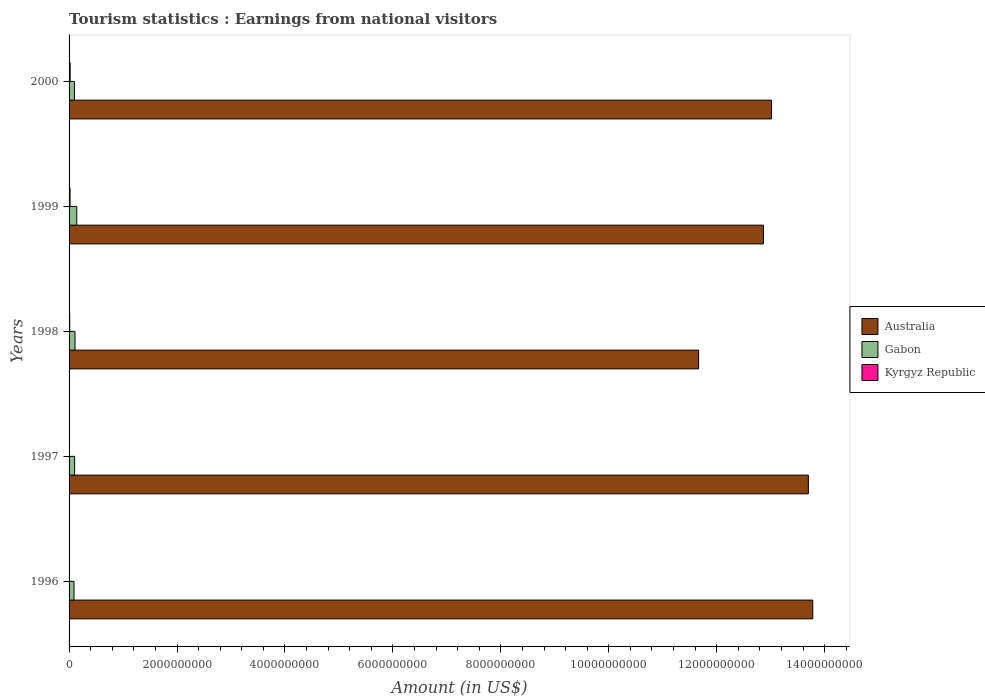How many groups of bars are there?
Your response must be concise. 5. Are the number of bars per tick equal to the number of legend labels?
Offer a very short reply. Yes. Are the number of bars on each tick of the Y-axis equal?
Keep it short and to the point. Yes. In how many cases, is the number of bars for a given year not equal to the number of legend labels?
Your response must be concise. 0. What is the earnings from national visitors in Gabon in 2000?
Ensure brevity in your answer.  9.90e+07. Across all years, what is the maximum earnings from national visitors in Kyrgyz Republic?
Offer a terse response. 2.00e+07. Across all years, what is the minimum earnings from national visitors in Kyrgyz Republic?
Make the answer very short. 4.00e+06. In which year was the earnings from national visitors in Gabon maximum?
Your answer should be very brief. 1999. In which year was the earnings from national visitors in Gabon minimum?
Provide a succinct answer. 1996. What is the total earnings from national visitors in Gabon in the graph?
Provide a short and direct response. 5.46e+08. What is the difference between the earnings from national visitors in Kyrgyz Republic in 1999 and that in 2000?
Make the answer very short. -2.00e+06. What is the difference between the earnings from national visitors in Australia in 1996 and the earnings from national visitors in Kyrgyz Republic in 2000?
Offer a very short reply. 1.38e+1. What is the average earnings from national visitors in Kyrgyz Republic per year?
Make the answer very short. 1.22e+07. In the year 1999, what is the difference between the earnings from national visitors in Kyrgyz Republic and earnings from national visitors in Australia?
Make the answer very short. -1.28e+1. In how many years, is the earnings from national visitors in Gabon greater than 11600000000 US$?
Ensure brevity in your answer.  0. What is the ratio of the earnings from national visitors in Australia in 1998 to that in 1999?
Provide a short and direct response. 0.91. Is the earnings from national visitors in Gabon in 1996 less than that in 2000?
Provide a short and direct response. Yes. Is the difference between the earnings from national visitors in Kyrgyz Republic in 1998 and 1999 greater than the difference between the earnings from national visitors in Australia in 1998 and 1999?
Your response must be concise. Yes. What is the difference between the highest and the second highest earnings from national visitors in Gabon?
Your answer should be very brief. 3.30e+07. What is the difference between the highest and the lowest earnings from national visitors in Gabon?
Ensure brevity in your answer.  5.20e+07. In how many years, is the earnings from national visitors in Australia greater than the average earnings from national visitors in Australia taken over all years?
Ensure brevity in your answer.  3. Is the sum of the earnings from national visitors in Australia in 1996 and 1998 greater than the maximum earnings from national visitors in Gabon across all years?
Offer a terse response. Yes. What does the 1st bar from the top in 2000 represents?
Ensure brevity in your answer.  Kyrgyz Republic. How many bars are there?
Your answer should be compact. 15. Are all the bars in the graph horizontal?
Your response must be concise. Yes. How many years are there in the graph?
Keep it short and to the point. 5. What is the difference between two consecutive major ticks on the X-axis?
Your response must be concise. 2.00e+09. Does the graph contain any zero values?
Provide a short and direct response. No. Does the graph contain grids?
Ensure brevity in your answer.  No. Where does the legend appear in the graph?
Ensure brevity in your answer.  Center right. How many legend labels are there?
Offer a terse response. 3. What is the title of the graph?
Your answer should be compact. Tourism statistics : Earnings from national visitors. Does "Georgia" appear as one of the legend labels in the graph?
Provide a succinct answer. No. What is the label or title of the X-axis?
Offer a terse response. Amount (in US$). What is the Amount (in US$) of Australia in 1996?
Keep it short and to the point. 1.38e+1. What is the Amount (in US$) in Gabon in 1996?
Offer a terse response. 9.10e+07. What is the Amount (in US$) in Kyrgyz Republic in 1996?
Ensure brevity in your answer.  4.00e+06. What is the Amount (in US$) of Australia in 1997?
Offer a terse response. 1.37e+1. What is the Amount (in US$) in Gabon in 1997?
Make the answer very short. 1.03e+08. What is the Amount (in US$) of Kyrgyz Republic in 1997?
Provide a short and direct response. 7.00e+06. What is the Amount (in US$) of Australia in 1998?
Offer a very short reply. 1.17e+1. What is the Amount (in US$) of Gabon in 1998?
Offer a terse response. 1.10e+08. What is the Amount (in US$) in Australia in 1999?
Your answer should be very brief. 1.29e+1. What is the Amount (in US$) in Gabon in 1999?
Make the answer very short. 1.43e+08. What is the Amount (in US$) of Kyrgyz Republic in 1999?
Offer a terse response. 1.80e+07. What is the Amount (in US$) of Australia in 2000?
Offer a terse response. 1.30e+1. What is the Amount (in US$) in Gabon in 2000?
Give a very brief answer. 9.90e+07. Across all years, what is the maximum Amount (in US$) in Australia?
Offer a terse response. 1.38e+1. Across all years, what is the maximum Amount (in US$) of Gabon?
Keep it short and to the point. 1.43e+08. Across all years, what is the minimum Amount (in US$) in Australia?
Your response must be concise. 1.17e+1. Across all years, what is the minimum Amount (in US$) in Gabon?
Your answer should be compact. 9.10e+07. Across all years, what is the minimum Amount (in US$) in Kyrgyz Republic?
Give a very brief answer. 4.00e+06. What is the total Amount (in US$) of Australia in the graph?
Ensure brevity in your answer.  6.50e+1. What is the total Amount (in US$) in Gabon in the graph?
Make the answer very short. 5.46e+08. What is the total Amount (in US$) of Kyrgyz Republic in the graph?
Make the answer very short. 6.10e+07. What is the difference between the Amount (in US$) of Australia in 1996 and that in 1997?
Offer a terse response. 8.10e+07. What is the difference between the Amount (in US$) of Gabon in 1996 and that in 1997?
Give a very brief answer. -1.20e+07. What is the difference between the Amount (in US$) of Kyrgyz Republic in 1996 and that in 1997?
Keep it short and to the point. -3.00e+06. What is the difference between the Amount (in US$) of Australia in 1996 and that in 1998?
Keep it short and to the point. 2.12e+09. What is the difference between the Amount (in US$) in Gabon in 1996 and that in 1998?
Offer a terse response. -1.90e+07. What is the difference between the Amount (in US$) of Kyrgyz Republic in 1996 and that in 1998?
Give a very brief answer. -8.00e+06. What is the difference between the Amount (in US$) in Australia in 1996 and that in 1999?
Make the answer very short. 9.13e+08. What is the difference between the Amount (in US$) of Gabon in 1996 and that in 1999?
Make the answer very short. -5.20e+07. What is the difference between the Amount (in US$) in Kyrgyz Republic in 1996 and that in 1999?
Your answer should be compact. -1.40e+07. What is the difference between the Amount (in US$) in Australia in 1996 and that in 2000?
Ensure brevity in your answer.  7.63e+08. What is the difference between the Amount (in US$) in Gabon in 1996 and that in 2000?
Your response must be concise. -8.00e+06. What is the difference between the Amount (in US$) of Kyrgyz Republic in 1996 and that in 2000?
Keep it short and to the point. -1.60e+07. What is the difference between the Amount (in US$) of Australia in 1997 and that in 1998?
Offer a very short reply. 2.03e+09. What is the difference between the Amount (in US$) of Gabon in 1997 and that in 1998?
Offer a terse response. -7.00e+06. What is the difference between the Amount (in US$) of Kyrgyz Republic in 1997 and that in 1998?
Your answer should be compact. -5.00e+06. What is the difference between the Amount (in US$) in Australia in 1997 and that in 1999?
Give a very brief answer. 8.32e+08. What is the difference between the Amount (in US$) in Gabon in 1997 and that in 1999?
Offer a very short reply. -4.00e+07. What is the difference between the Amount (in US$) of Kyrgyz Republic in 1997 and that in 1999?
Make the answer very short. -1.10e+07. What is the difference between the Amount (in US$) in Australia in 1997 and that in 2000?
Ensure brevity in your answer.  6.82e+08. What is the difference between the Amount (in US$) of Gabon in 1997 and that in 2000?
Provide a short and direct response. 4.00e+06. What is the difference between the Amount (in US$) of Kyrgyz Republic in 1997 and that in 2000?
Your answer should be compact. -1.30e+07. What is the difference between the Amount (in US$) in Australia in 1998 and that in 1999?
Offer a terse response. -1.20e+09. What is the difference between the Amount (in US$) of Gabon in 1998 and that in 1999?
Your answer should be compact. -3.30e+07. What is the difference between the Amount (in US$) of Kyrgyz Republic in 1998 and that in 1999?
Give a very brief answer. -6.00e+06. What is the difference between the Amount (in US$) in Australia in 1998 and that in 2000?
Your answer should be compact. -1.35e+09. What is the difference between the Amount (in US$) in Gabon in 1998 and that in 2000?
Provide a short and direct response. 1.10e+07. What is the difference between the Amount (in US$) of Kyrgyz Republic in 1998 and that in 2000?
Offer a terse response. -8.00e+06. What is the difference between the Amount (in US$) of Australia in 1999 and that in 2000?
Offer a terse response. -1.50e+08. What is the difference between the Amount (in US$) in Gabon in 1999 and that in 2000?
Ensure brevity in your answer.  4.40e+07. What is the difference between the Amount (in US$) in Kyrgyz Republic in 1999 and that in 2000?
Your answer should be compact. -2.00e+06. What is the difference between the Amount (in US$) of Australia in 1996 and the Amount (in US$) of Gabon in 1997?
Provide a succinct answer. 1.37e+1. What is the difference between the Amount (in US$) of Australia in 1996 and the Amount (in US$) of Kyrgyz Republic in 1997?
Provide a short and direct response. 1.38e+1. What is the difference between the Amount (in US$) in Gabon in 1996 and the Amount (in US$) in Kyrgyz Republic in 1997?
Provide a short and direct response. 8.40e+07. What is the difference between the Amount (in US$) in Australia in 1996 and the Amount (in US$) in Gabon in 1998?
Provide a succinct answer. 1.37e+1. What is the difference between the Amount (in US$) of Australia in 1996 and the Amount (in US$) of Kyrgyz Republic in 1998?
Your answer should be compact. 1.38e+1. What is the difference between the Amount (in US$) in Gabon in 1996 and the Amount (in US$) in Kyrgyz Republic in 1998?
Ensure brevity in your answer.  7.90e+07. What is the difference between the Amount (in US$) of Australia in 1996 and the Amount (in US$) of Gabon in 1999?
Give a very brief answer. 1.36e+1. What is the difference between the Amount (in US$) in Australia in 1996 and the Amount (in US$) in Kyrgyz Republic in 1999?
Your answer should be compact. 1.38e+1. What is the difference between the Amount (in US$) in Gabon in 1996 and the Amount (in US$) in Kyrgyz Republic in 1999?
Your answer should be very brief. 7.30e+07. What is the difference between the Amount (in US$) of Australia in 1996 and the Amount (in US$) of Gabon in 2000?
Keep it short and to the point. 1.37e+1. What is the difference between the Amount (in US$) in Australia in 1996 and the Amount (in US$) in Kyrgyz Republic in 2000?
Your response must be concise. 1.38e+1. What is the difference between the Amount (in US$) of Gabon in 1996 and the Amount (in US$) of Kyrgyz Republic in 2000?
Offer a very short reply. 7.10e+07. What is the difference between the Amount (in US$) of Australia in 1997 and the Amount (in US$) of Gabon in 1998?
Make the answer very short. 1.36e+1. What is the difference between the Amount (in US$) in Australia in 1997 and the Amount (in US$) in Kyrgyz Republic in 1998?
Ensure brevity in your answer.  1.37e+1. What is the difference between the Amount (in US$) in Gabon in 1997 and the Amount (in US$) in Kyrgyz Republic in 1998?
Offer a terse response. 9.10e+07. What is the difference between the Amount (in US$) of Australia in 1997 and the Amount (in US$) of Gabon in 1999?
Your answer should be compact. 1.36e+1. What is the difference between the Amount (in US$) in Australia in 1997 and the Amount (in US$) in Kyrgyz Republic in 1999?
Offer a very short reply. 1.37e+1. What is the difference between the Amount (in US$) in Gabon in 1997 and the Amount (in US$) in Kyrgyz Republic in 1999?
Keep it short and to the point. 8.50e+07. What is the difference between the Amount (in US$) in Australia in 1997 and the Amount (in US$) in Gabon in 2000?
Provide a short and direct response. 1.36e+1. What is the difference between the Amount (in US$) of Australia in 1997 and the Amount (in US$) of Kyrgyz Republic in 2000?
Keep it short and to the point. 1.37e+1. What is the difference between the Amount (in US$) of Gabon in 1997 and the Amount (in US$) of Kyrgyz Republic in 2000?
Your answer should be very brief. 8.30e+07. What is the difference between the Amount (in US$) of Australia in 1998 and the Amount (in US$) of Gabon in 1999?
Provide a succinct answer. 1.15e+1. What is the difference between the Amount (in US$) in Australia in 1998 and the Amount (in US$) in Kyrgyz Republic in 1999?
Offer a terse response. 1.16e+1. What is the difference between the Amount (in US$) of Gabon in 1998 and the Amount (in US$) of Kyrgyz Republic in 1999?
Give a very brief answer. 9.20e+07. What is the difference between the Amount (in US$) of Australia in 1998 and the Amount (in US$) of Gabon in 2000?
Your answer should be very brief. 1.16e+1. What is the difference between the Amount (in US$) in Australia in 1998 and the Amount (in US$) in Kyrgyz Republic in 2000?
Make the answer very short. 1.16e+1. What is the difference between the Amount (in US$) in Gabon in 1998 and the Amount (in US$) in Kyrgyz Republic in 2000?
Your answer should be very brief. 9.00e+07. What is the difference between the Amount (in US$) of Australia in 1999 and the Amount (in US$) of Gabon in 2000?
Provide a short and direct response. 1.28e+1. What is the difference between the Amount (in US$) in Australia in 1999 and the Amount (in US$) in Kyrgyz Republic in 2000?
Offer a very short reply. 1.28e+1. What is the difference between the Amount (in US$) of Gabon in 1999 and the Amount (in US$) of Kyrgyz Republic in 2000?
Your response must be concise. 1.23e+08. What is the average Amount (in US$) in Australia per year?
Your response must be concise. 1.30e+1. What is the average Amount (in US$) of Gabon per year?
Your answer should be very brief. 1.09e+08. What is the average Amount (in US$) of Kyrgyz Republic per year?
Provide a short and direct response. 1.22e+07. In the year 1996, what is the difference between the Amount (in US$) of Australia and Amount (in US$) of Gabon?
Your response must be concise. 1.37e+1. In the year 1996, what is the difference between the Amount (in US$) of Australia and Amount (in US$) of Kyrgyz Republic?
Your response must be concise. 1.38e+1. In the year 1996, what is the difference between the Amount (in US$) in Gabon and Amount (in US$) in Kyrgyz Republic?
Offer a terse response. 8.70e+07. In the year 1997, what is the difference between the Amount (in US$) in Australia and Amount (in US$) in Gabon?
Provide a succinct answer. 1.36e+1. In the year 1997, what is the difference between the Amount (in US$) in Australia and Amount (in US$) in Kyrgyz Republic?
Provide a succinct answer. 1.37e+1. In the year 1997, what is the difference between the Amount (in US$) in Gabon and Amount (in US$) in Kyrgyz Republic?
Provide a short and direct response. 9.60e+07. In the year 1998, what is the difference between the Amount (in US$) of Australia and Amount (in US$) of Gabon?
Keep it short and to the point. 1.16e+1. In the year 1998, what is the difference between the Amount (in US$) of Australia and Amount (in US$) of Kyrgyz Republic?
Your answer should be compact. 1.17e+1. In the year 1998, what is the difference between the Amount (in US$) in Gabon and Amount (in US$) in Kyrgyz Republic?
Your answer should be compact. 9.80e+07. In the year 1999, what is the difference between the Amount (in US$) of Australia and Amount (in US$) of Gabon?
Your response must be concise. 1.27e+1. In the year 1999, what is the difference between the Amount (in US$) in Australia and Amount (in US$) in Kyrgyz Republic?
Your response must be concise. 1.28e+1. In the year 1999, what is the difference between the Amount (in US$) in Gabon and Amount (in US$) in Kyrgyz Republic?
Provide a short and direct response. 1.25e+08. In the year 2000, what is the difference between the Amount (in US$) of Australia and Amount (in US$) of Gabon?
Provide a succinct answer. 1.29e+1. In the year 2000, what is the difference between the Amount (in US$) in Australia and Amount (in US$) in Kyrgyz Republic?
Offer a terse response. 1.30e+1. In the year 2000, what is the difference between the Amount (in US$) of Gabon and Amount (in US$) of Kyrgyz Republic?
Your answer should be compact. 7.90e+07. What is the ratio of the Amount (in US$) in Australia in 1996 to that in 1997?
Your answer should be compact. 1.01. What is the ratio of the Amount (in US$) of Gabon in 1996 to that in 1997?
Your answer should be very brief. 0.88. What is the ratio of the Amount (in US$) in Australia in 1996 to that in 1998?
Your answer should be very brief. 1.18. What is the ratio of the Amount (in US$) in Gabon in 1996 to that in 1998?
Keep it short and to the point. 0.83. What is the ratio of the Amount (in US$) of Australia in 1996 to that in 1999?
Make the answer very short. 1.07. What is the ratio of the Amount (in US$) in Gabon in 1996 to that in 1999?
Give a very brief answer. 0.64. What is the ratio of the Amount (in US$) of Kyrgyz Republic in 1996 to that in 1999?
Offer a terse response. 0.22. What is the ratio of the Amount (in US$) in Australia in 1996 to that in 2000?
Make the answer very short. 1.06. What is the ratio of the Amount (in US$) in Gabon in 1996 to that in 2000?
Provide a succinct answer. 0.92. What is the ratio of the Amount (in US$) of Kyrgyz Republic in 1996 to that in 2000?
Keep it short and to the point. 0.2. What is the ratio of the Amount (in US$) of Australia in 1997 to that in 1998?
Your answer should be very brief. 1.17. What is the ratio of the Amount (in US$) in Gabon in 1997 to that in 1998?
Make the answer very short. 0.94. What is the ratio of the Amount (in US$) of Kyrgyz Republic in 1997 to that in 1998?
Your answer should be very brief. 0.58. What is the ratio of the Amount (in US$) of Australia in 1997 to that in 1999?
Provide a short and direct response. 1.06. What is the ratio of the Amount (in US$) in Gabon in 1997 to that in 1999?
Provide a short and direct response. 0.72. What is the ratio of the Amount (in US$) in Kyrgyz Republic in 1997 to that in 1999?
Offer a very short reply. 0.39. What is the ratio of the Amount (in US$) in Australia in 1997 to that in 2000?
Offer a very short reply. 1.05. What is the ratio of the Amount (in US$) in Gabon in 1997 to that in 2000?
Provide a succinct answer. 1.04. What is the ratio of the Amount (in US$) of Australia in 1998 to that in 1999?
Provide a succinct answer. 0.91. What is the ratio of the Amount (in US$) of Gabon in 1998 to that in 1999?
Your response must be concise. 0.77. What is the ratio of the Amount (in US$) in Australia in 1998 to that in 2000?
Provide a short and direct response. 0.9. What is the ratio of the Amount (in US$) of Gabon in 1998 to that in 2000?
Make the answer very short. 1.11. What is the ratio of the Amount (in US$) in Australia in 1999 to that in 2000?
Your answer should be very brief. 0.99. What is the ratio of the Amount (in US$) of Gabon in 1999 to that in 2000?
Provide a short and direct response. 1.44. What is the ratio of the Amount (in US$) of Kyrgyz Republic in 1999 to that in 2000?
Your answer should be very brief. 0.9. What is the difference between the highest and the second highest Amount (in US$) in Australia?
Provide a succinct answer. 8.10e+07. What is the difference between the highest and the second highest Amount (in US$) in Gabon?
Provide a succinct answer. 3.30e+07. What is the difference between the highest and the lowest Amount (in US$) of Australia?
Your answer should be compact. 2.12e+09. What is the difference between the highest and the lowest Amount (in US$) of Gabon?
Provide a succinct answer. 5.20e+07. What is the difference between the highest and the lowest Amount (in US$) in Kyrgyz Republic?
Ensure brevity in your answer.  1.60e+07. 